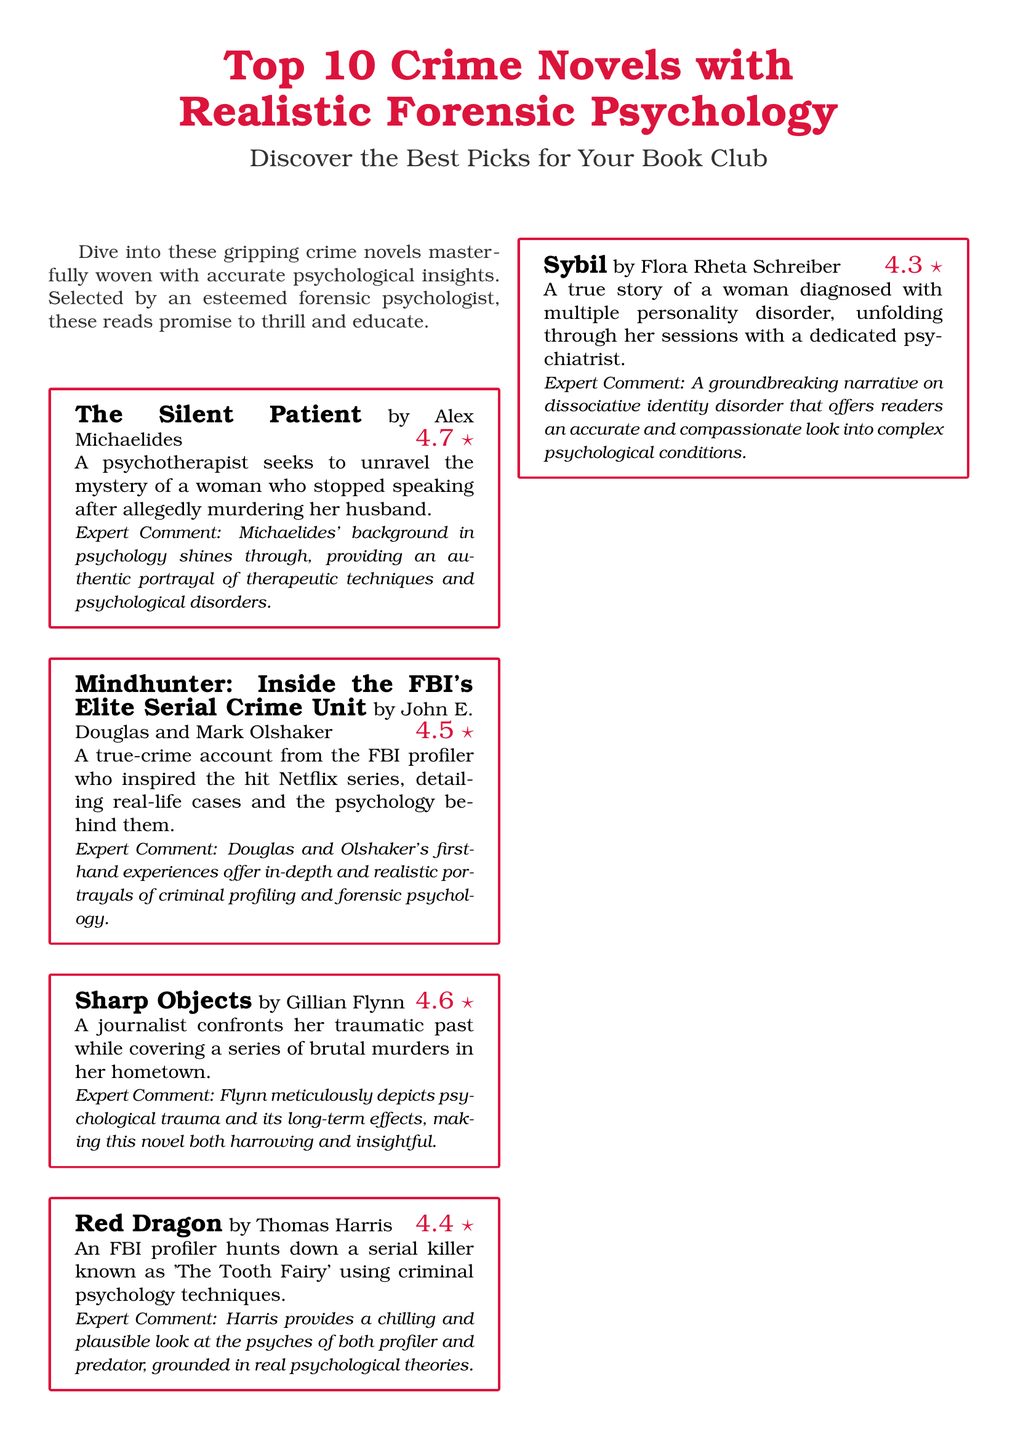What is the title of the flyer? The title of the flyer introduces the main topic and is presented at the top.
Answer: Top 10 Crime Novels with Realistic Forensic Psychology How many stars does "The Silent Patient" have? The star rating for "The Silent Patient" can be found next to its title on the flyer.
Answer: 4.7 Who is the author of "Mindhunter"? The author of "Mindhunter" is listed in the book entry section of the flyer.
Answer: John E. Douglas and Mark Olshaker What psychological disorder is explored in "Sybil"? The book entry for "Sybil" describes the condition that the protagonist is diagnosed with.
Answer: Multiple personality disorder Which book features a quadriplegic detective? This detail can be found in the summary of one of the book entries listed.
Answer: The Bone Collector What is the primary theme of "Gone Girl"? The primary theme is indicated in the summary provided with the book entry.
Answer: Psychological manipulation How many books received a star rating of 4.6? The number of books with a particular rating can be totaled from the ratings provided in the document.
Answer: 3 Which author has two entries on the list? This question requires reasoning through the entries to identify repeated authors.
Answer: Gillian Flynn What genre do these novels belong to? The general category of the novels is indicated at the beginning of the flyer.
Answer: Crime novels 